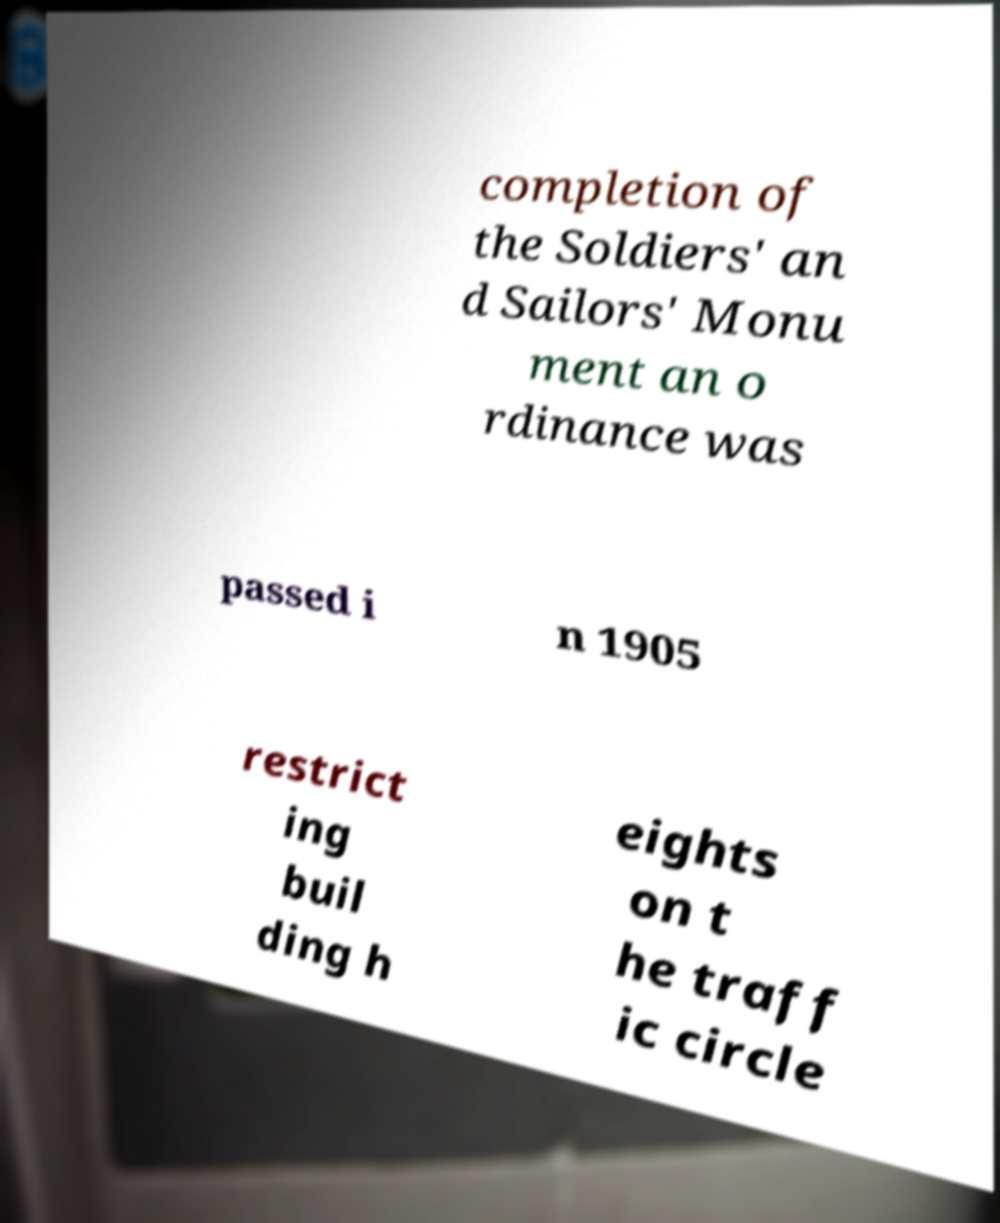Can you read and provide the text displayed in the image?This photo seems to have some interesting text. Can you extract and type it out for me? completion of the Soldiers' an d Sailors' Monu ment an o rdinance was passed i n 1905 restrict ing buil ding h eights on t he traff ic circle 